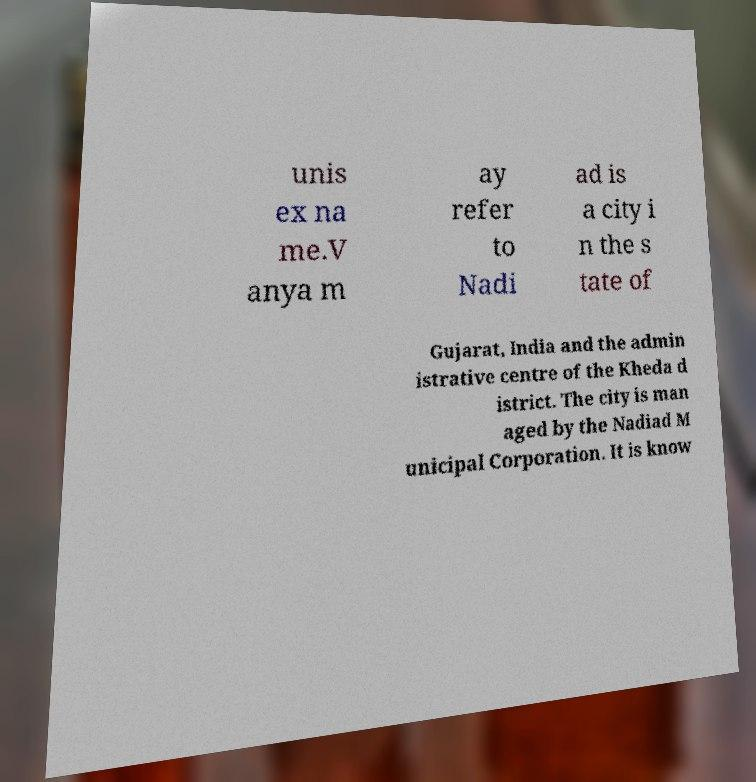Can you read and provide the text displayed in the image?This photo seems to have some interesting text. Can you extract and type it out for me? unis ex na me.V anya m ay refer to Nadi ad is a city i n the s tate of Gujarat, India and the admin istrative centre of the Kheda d istrict. The city is man aged by the Nadiad M unicipal Corporation. It is know 